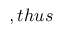<formula> <loc_0><loc_0><loc_500><loc_500>, t h u s</formula> 